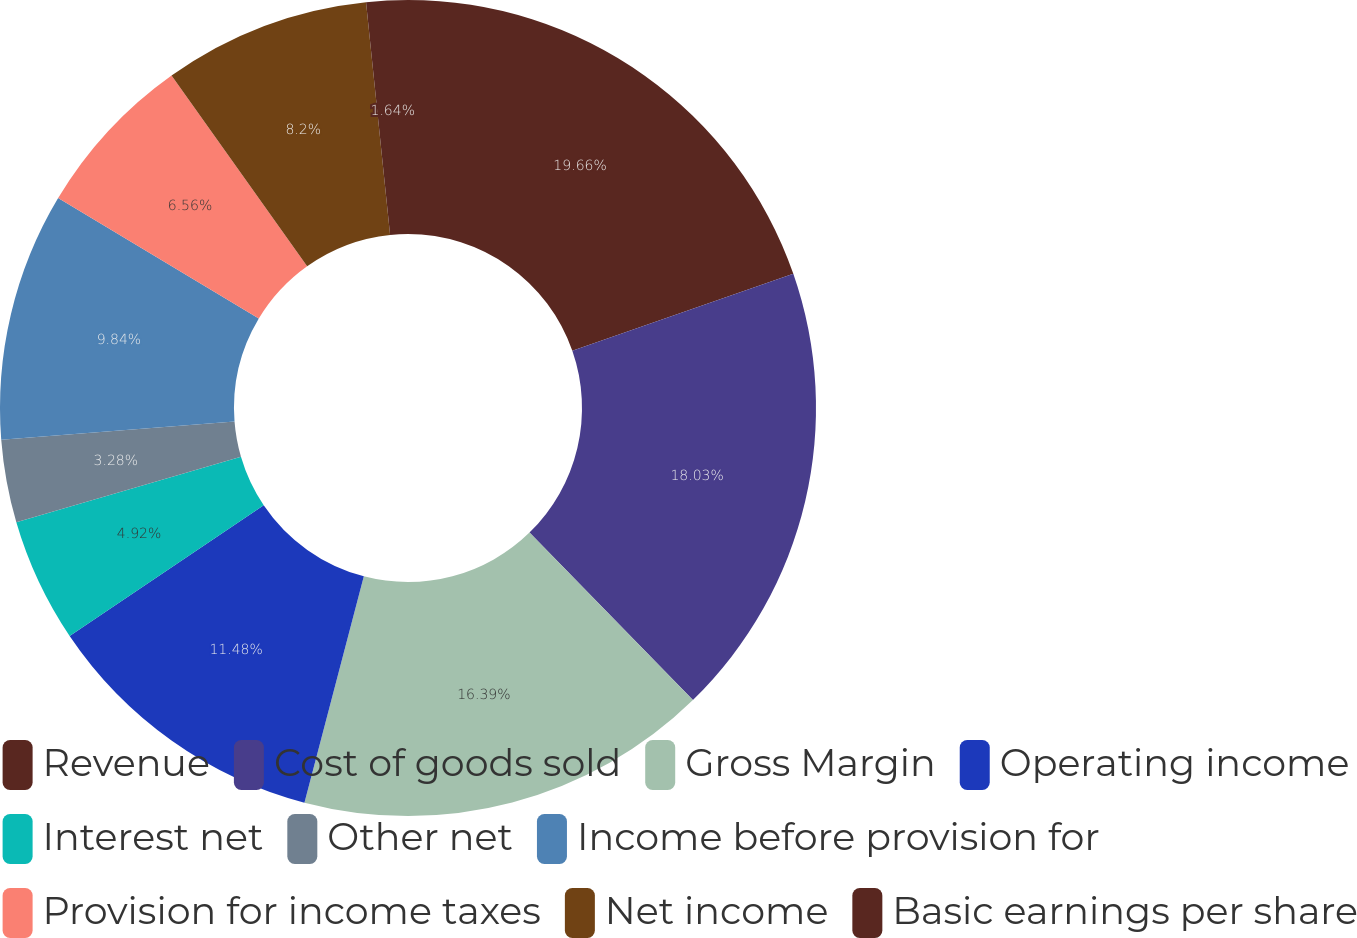<chart> <loc_0><loc_0><loc_500><loc_500><pie_chart><fcel>Revenue<fcel>Cost of goods sold<fcel>Gross Margin<fcel>Operating income<fcel>Interest net<fcel>Other net<fcel>Income before provision for<fcel>Provision for income taxes<fcel>Net income<fcel>Basic earnings per share<nl><fcel>19.67%<fcel>18.03%<fcel>16.39%<fcel>11.48%<fcel>4.92%<fcel>3.28%<fcel>9.84%<fcel>6.56%<fcel>8.2%<fcel>1.64%<nl></chart> 